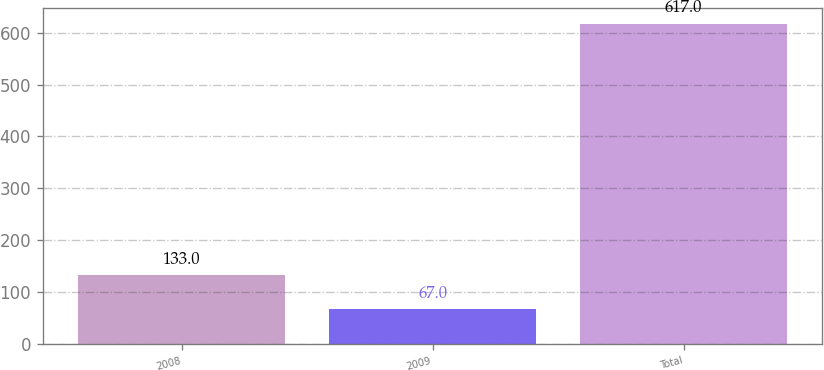Convert chart to OTSL. <chart><loc_0><loc_0><loc_500><loc_500><bar_chart><fcel>2008<fcel>2009<fcel>Total<nl><fcel>133<fcel>67<fcel>617<nl></chart> 